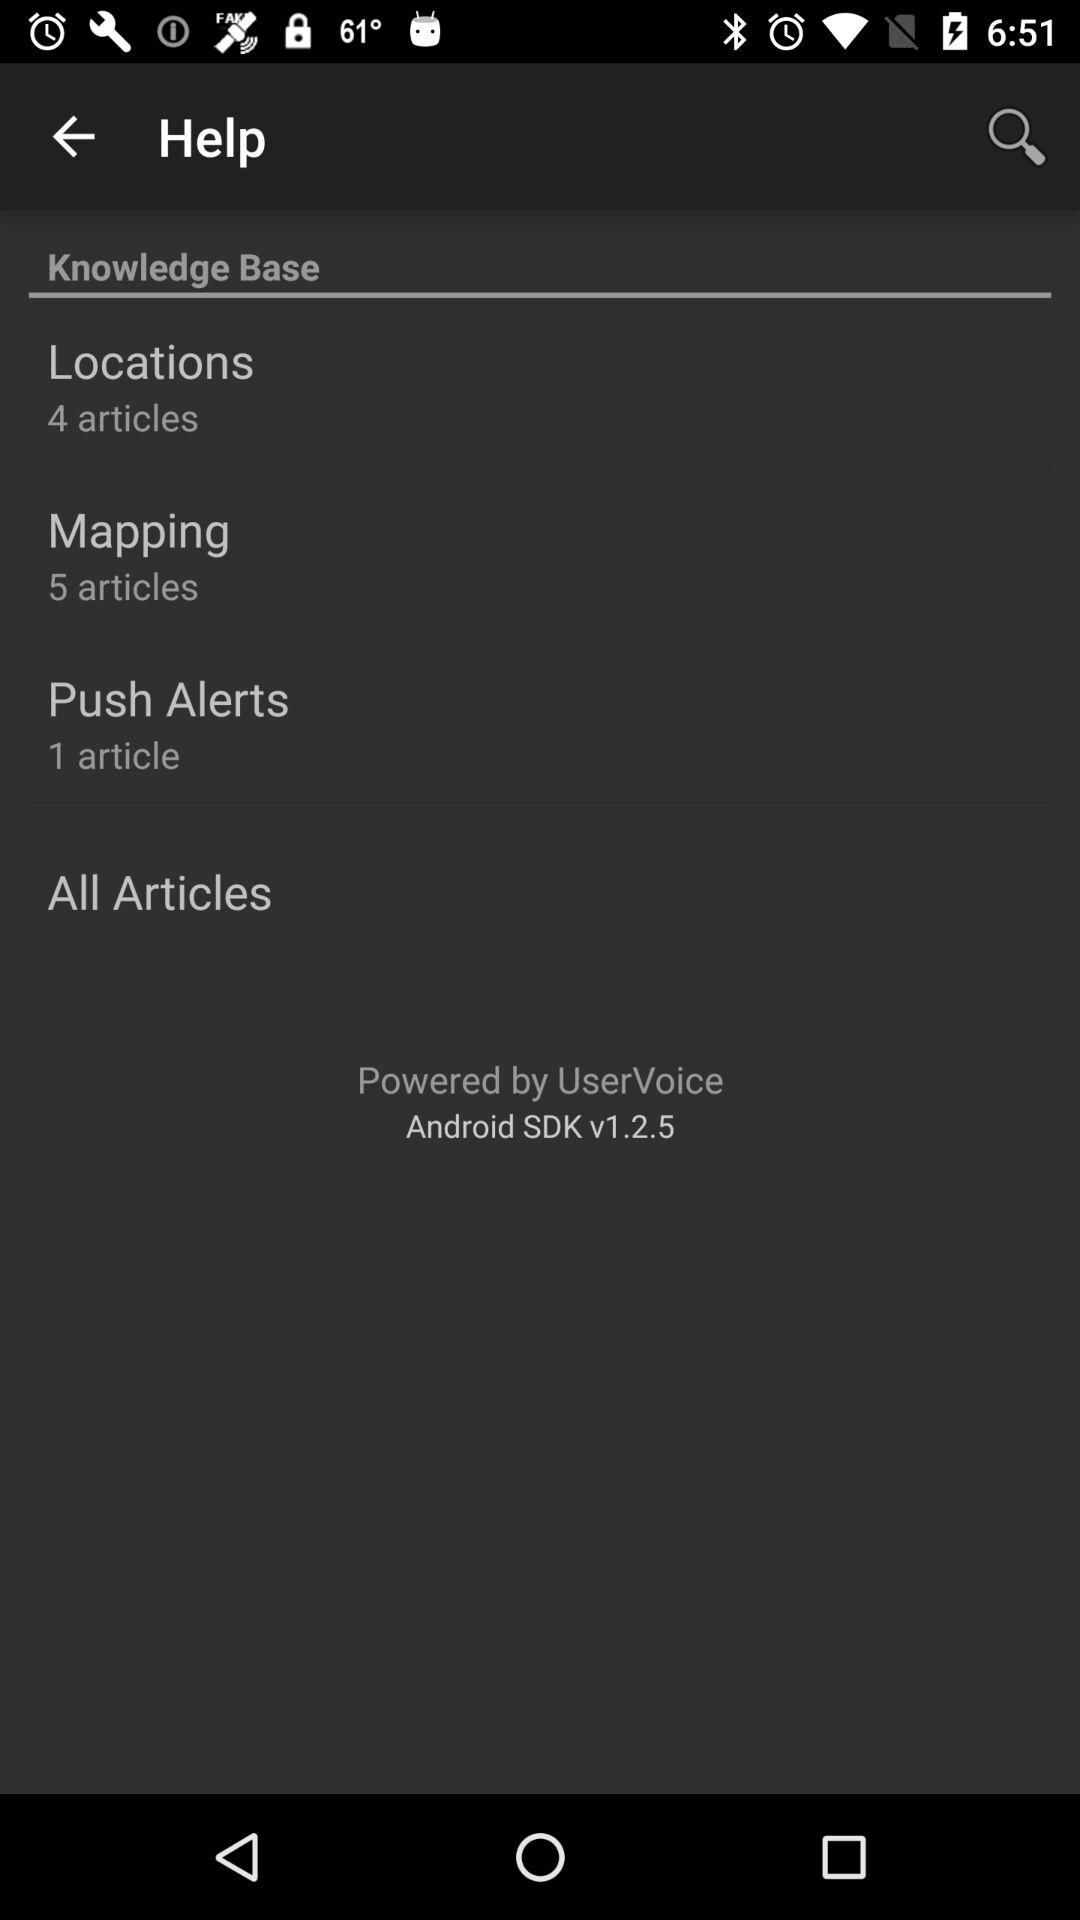What is the number of articles in "Push Alerts"? The number of articles in "Push Alerts" is 1. 